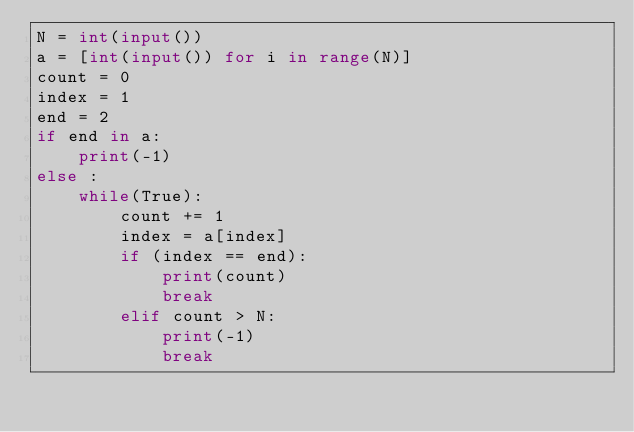Convert code to text. <code><loc_0><loc_0><loc_500><loc_500><_Python_>N = int(input())
a = [int(input()) for i in range(N)]
count = 0
index = 1
end = 2
if end in a:
    print(-1)
else :
    while(True):
        count += 1
        index = a[index]
        if (index == end):
            print(count)
            break
        elif count > N:
            print(-1)
            break</code> 